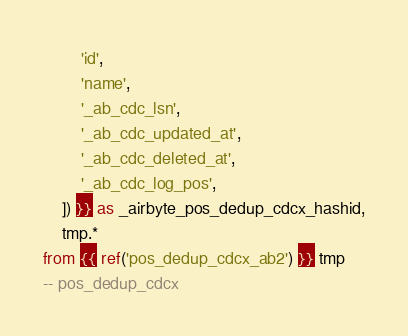Convert code to text. <code><loc_0><loc_0><loc_500><loc_500><_SQL_>        'id',
        'name',
        '_ab_cdc_lsn',
        '_ab_cdc_updated_at',
        '_ab_cdc_deleted_at',
        '_ab_cdc_log_pos',
    ]) }} as _airbyte_pos_dedup_cdcx_hashid,
    tmp.*
from {{ ref('pos_dedup_cdcx_ab2') }} tmp
-- pos_dedup_cdcx

</code> 